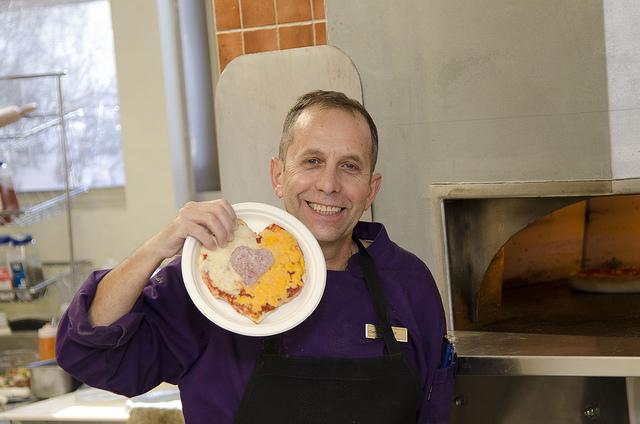What food is the heart shaped object made of? pizza 